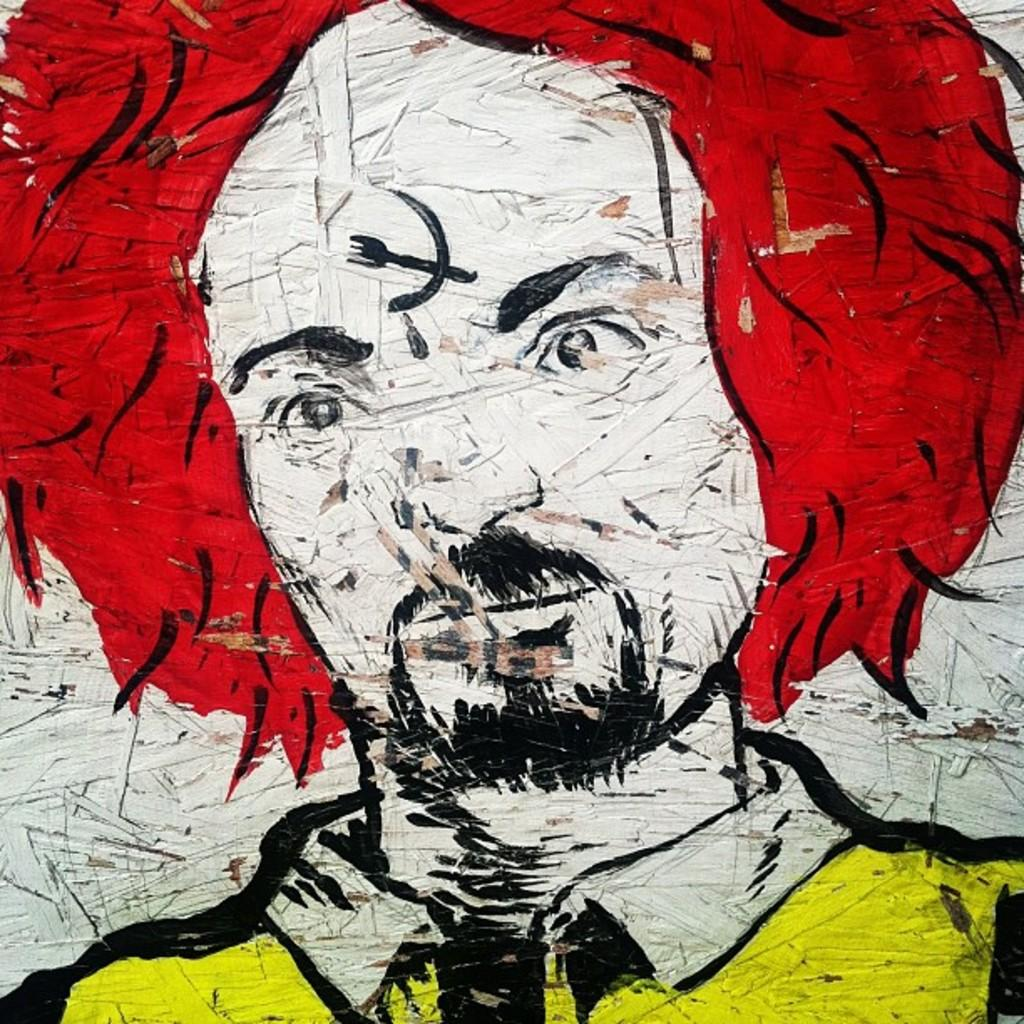What is the main subject of the painting in the image? There is a painting of a person in the image. What type of wax is used to create the person's hair in the painting? There is no information about the materials used in the painting, and the image does not show the person's hair. 